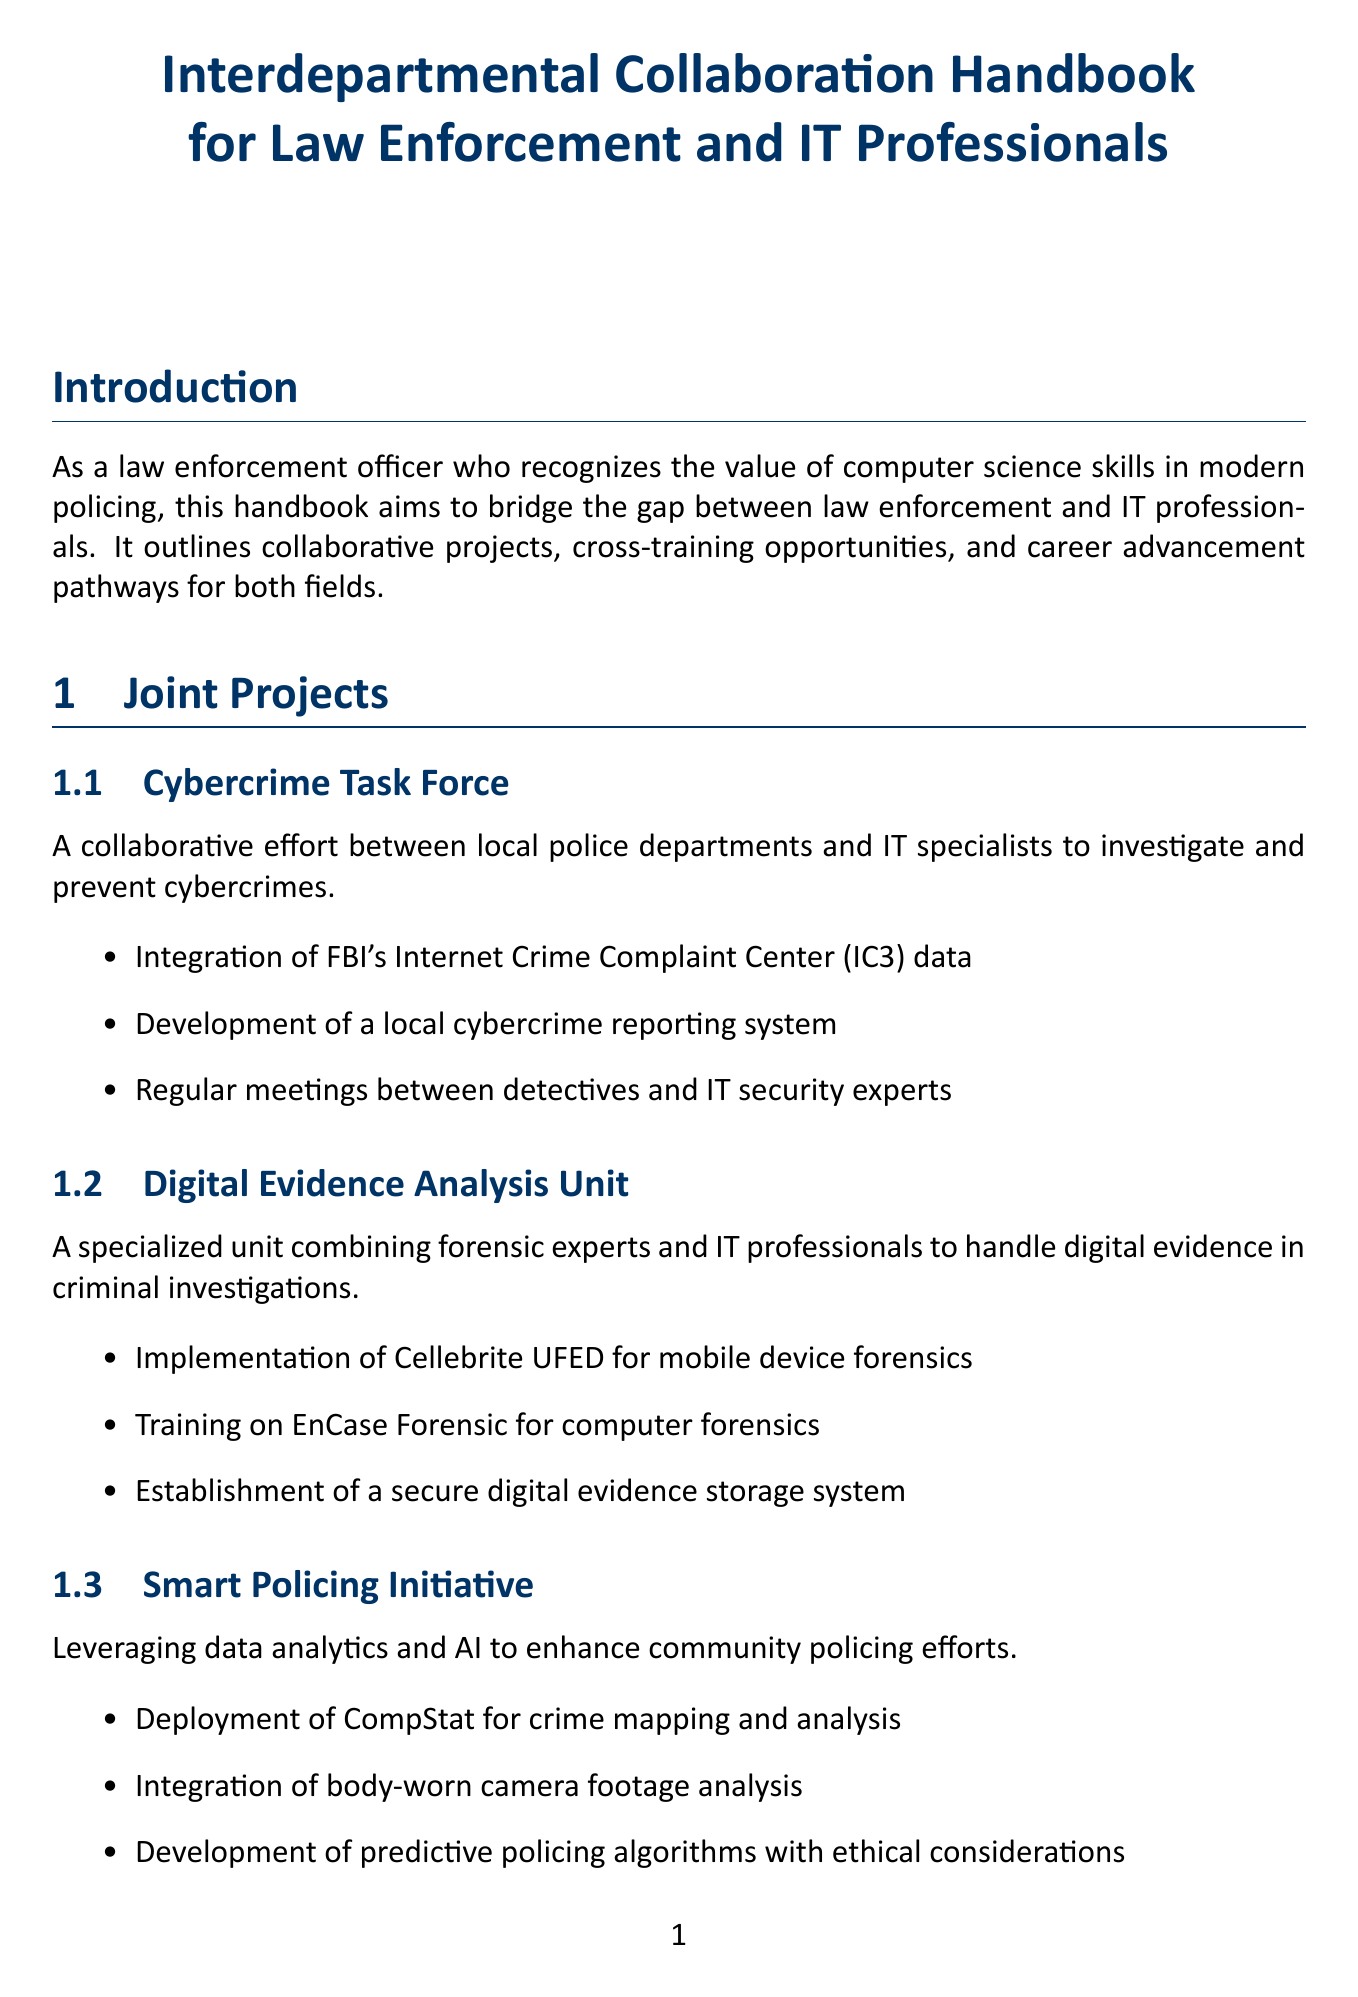What is the main purpose of this handbook? The handbook aims to bridge the gap between law enforcement and IT professionals and outlines collaborative projects, cross-training opportunities, and career advancement pathways for both fields.
Answer: Bridge the gap between law enforcement and IT professionals What program is offered for comprehensive training in digital forensics? The program that provides comprehensive training in digital forensics techniques for law enforcement officers is listed under cross-training opportunities.
Answer: Digital Forensics Certification How long is the "Cybersecurity for Law Enforcement" course? The duration of the "Cybersecurity for Law Enforcement" course is stated in the cross-training section.
Answer: 2 weeks What outcomes were achieved in the "Operation Dark Web Takedown"? This question requires recalling main results from a case study in the document.
Answer: Arrest of 50 individuals across 3 states What are the requirements to become a Cybercrime Investigator? The specific academic and certification requirements for the role of Cybercrime Investigator are detailed in the career advancement pathways section.
Answer: Law enforcement experience, Bachelor's degree in Computer Science or related field, Digital Forensics Certification, FBI Cyber Investigator Certification What is a key recommendation for successful collaboration? Recommendations for collaboration practices are outlined in the best practices section.
Answer: Establish clear communication channels between IT and law enforcement personnel Which unit focuses on handling digital evidence in criminal investigations? This unit is mentioned under the joint projects section and combines various professionals.
Answer: Digital Evidence Analysis Unit What certification is needed for an Information Security Officer? The necessary qualification required for an Information Security Officer is mentioned in the career advancement pathways section.
Answer: CISSP Certification 